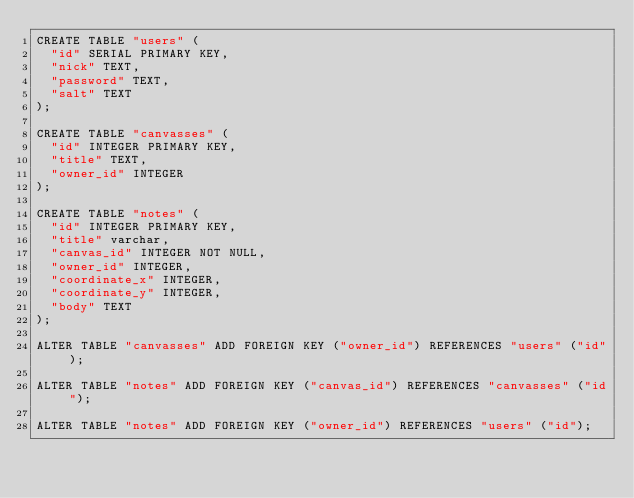Convert code to text. <code><loc_0><loc_0><loc_500><loc_500><_SQL_>CREATE TABLE "users" (
  "id" SERIAL PRIMARY KEY,
  "nick" TEXT,
  "password" TEXT,
  "salt" TEXT
);

CREATE TABLE "canvasses" (
  "id" INTEGER PRIMARY KEY,
  "title" TEXT,
  "owner_id" INTEGER
);

CREATE TABLE "notes" (
  "id" INTEGER PRIMARY KEY,
  "title" varchar,
  "canvas_id" INTEGER NOT NULL,
  "owner_id" INTEGER,
  "coordinate_x" INTEGER,
  "coordinate_y" INTEGER,
  "body" TEXT
);

ALTER TABLE "canvasses" ADD FOREIGN KEY ("owner_id") REFERENCES "users" ("id");

ALTER TABLE "notes" ADD FOREIGN KEY ("canvas_id") REFERENCES "canvasses" ("id");

ALTER TABLE "notes" ADD FOREIGN KEY ("owner_id") REFERENCES "users" ("id");
</code> 